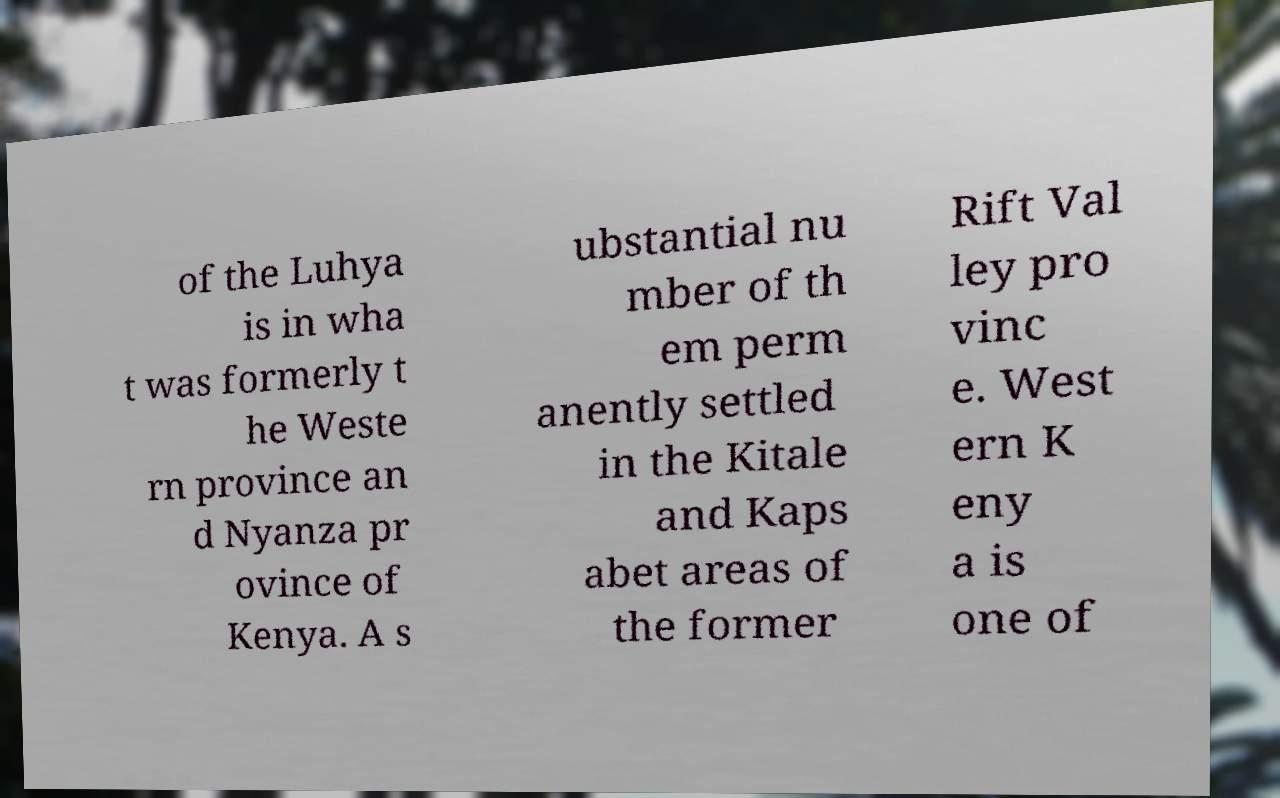Could you extract and type out the text from this image? of the Luhya is in wha t was formerly t he Weste rn province an d Nyanza pr ovince of Kenya. A s ubstantial nu mber of th em perm anently settled in the Kitale and Kaps abet areas of the former Rift Val ley pro vinc e. West ern K eny a is one of 